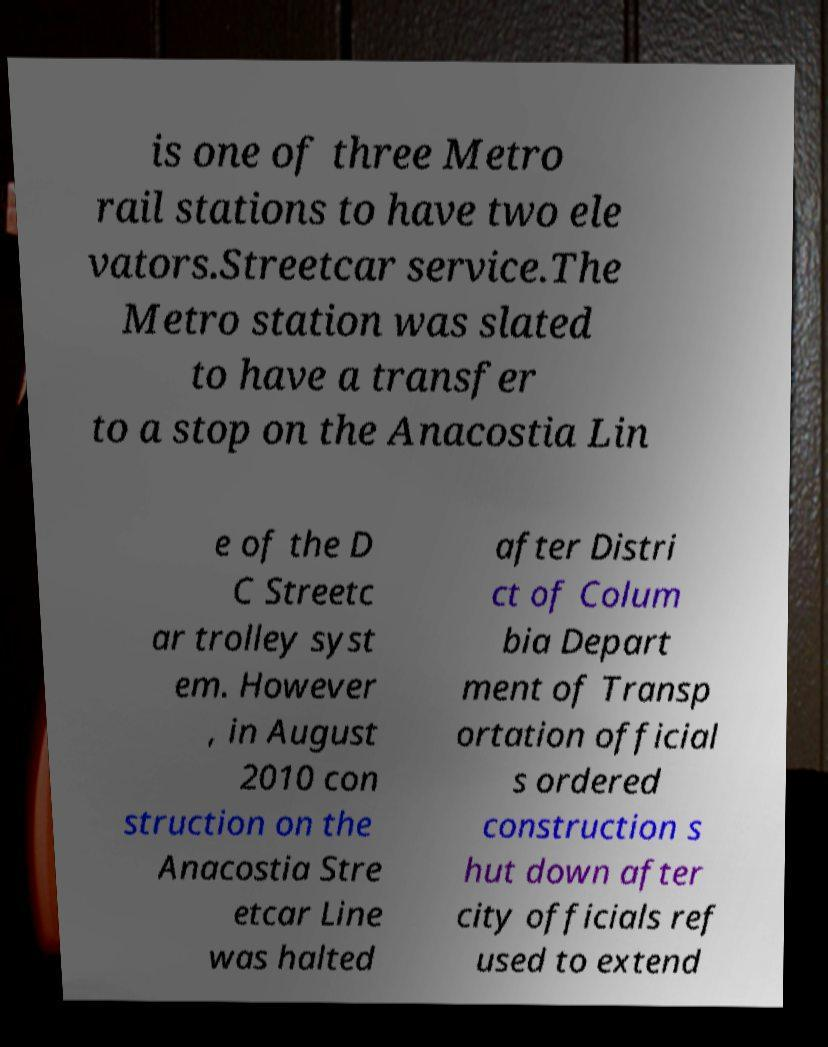For documentation purposes, I need the text within this image transcribed. Could you provide that? is one of three Metro rail stations to have two ele vators.Streetcar service.The Metro station was slated to have a transfer to a stop on the Anacostia Lin e of the D C Streetc ar trolley syst em. However , in August 2010 con struction on the Anacostia Stre etcar Line was halted after Distri ct of Colum bia Depart ment of Transp ortation official s ordered construction s hut down after city officials ref used to extend 